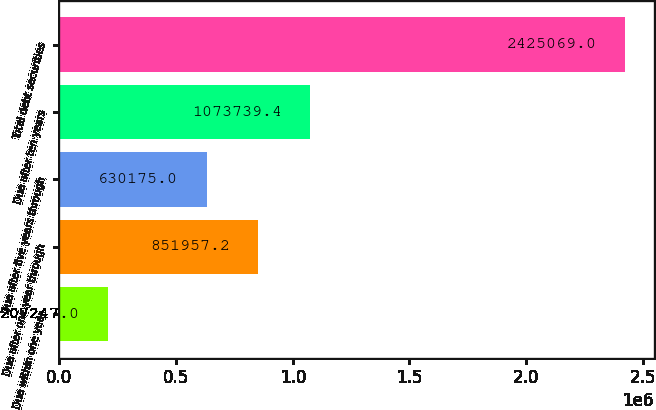<chart> <loc_0><loc_0><loc_500><loc_500><bar_chart><fcel>Due within one year<fcel>Due after one year through<fcel>Due after five years through<fcel>Due after ten years<fcel>Total debt securities<nl><fcel>207247<fcel>851957<fcel>630175<fcel>1.07374e+06<fcel>2.42507e+06<nl></chart> 